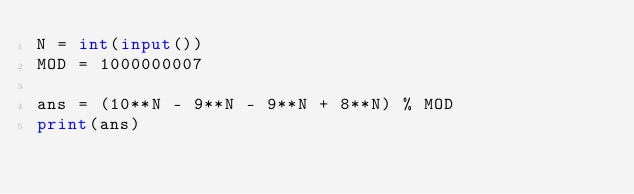<code> <loc_0><loc_0><loc_500><loc_500><_Python_>N = int(input())
MOD = 1000000007

ans = (10**N - 9**N - 9**N + 8**N) % MOD
print(ans)</code> 